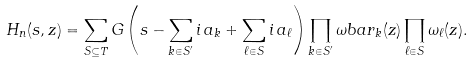Convert formula to latex. <formula><loc_0><loc_0><loc_500><loc_500>H _ { n } ( s , z ) = \sum _ { S \subseteq T } G \left ( s - \sum _ { k \in S ^ { \prime } } i \, a _ { k } + \sum _ { \ell \in S } i \, a _ { \ell } \right ) \prod _ { k \in S ^ { \prime } } \omega b a r _ { k } ( z ) \prod _ { \ell \in S } \omega _ { \ell } ( z ) .</formula> 